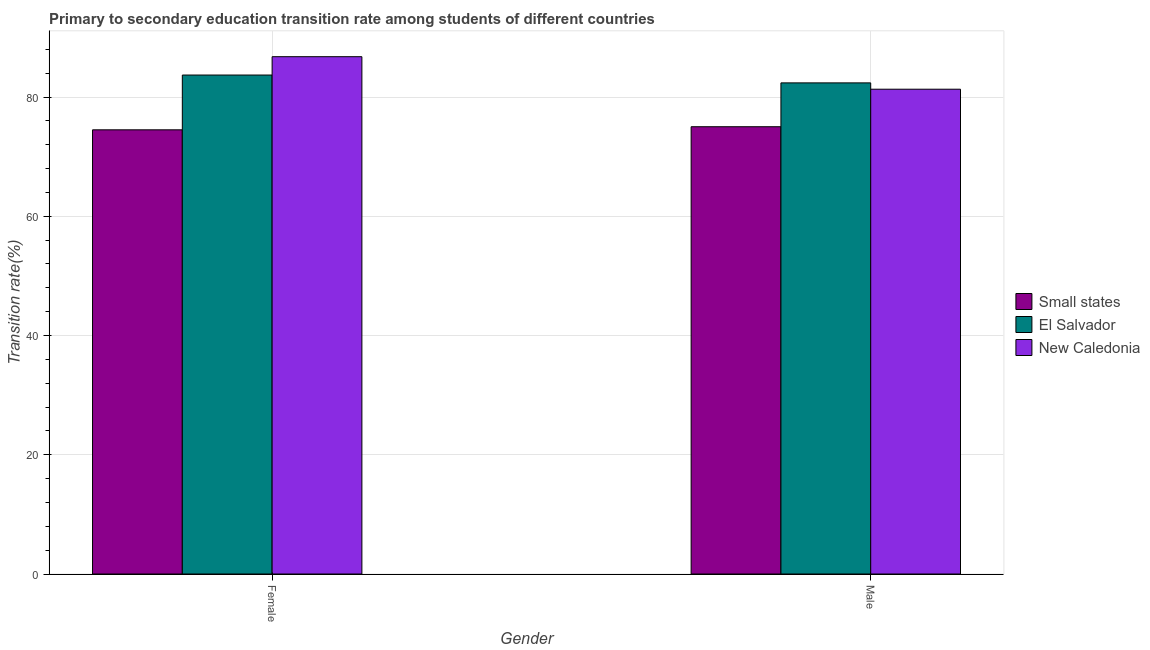How many different coloured bars are there?
Your response must be concise. 3. Are the number of bars per tick equal to the number of legend labels?
Keep it short and to the point. Yes. What is the label of the 1st group of bars from the left?
Provide a short and direct response. Female. What is the transition rate among male students in Small states?
Ensure brevity in your answer.  75.02. Across all countries, what is the maximum transition rate among male students?
Provide a short and direct response. 82.38. Across all countries, what is the minimum transition rate among male students?
Offer a very short reply. 75.02. In which country was the transition rate among female students maximum?
Offer a terse response. New Caledonia. In which country was the transition rate among male students minimum?
Offer a terse response. Small states. What is the total transition rate among male students in the graph?
Provide a succinct answer. 238.71. What is the difference between the transition rate among male students in El Salvador and that in Small states?
Give a very brief answer. 7.35. What is the difference between the transition rate among female students in El Salvador and the transition rate among male students in Small states?
Make the answer very short. 8.67. What is the average transition rate among female students per country?
Give a very brief answer. 81.65. What is the difference between the transition rate among male students and transition rate among female students in New Caledonia?
Provide a succinct answer. -5.45. What is the ratio of the transition rate among female students in Small states to that in New Caledonia?
Offer a terse response. 0.86. Is the transition rate among female students in El Salvador less than that in Small states?
Provide a succinct answer. No. In how many countries, is the transition rate among female students greater than the average transition rate among female students taken over all countries?
Ensure brevity in your answer.  2. What does the 3rd bar from the left in Female represents?
Your answer should be compact. New Caledonia. What does the 1st bar from the right in Male represents?
Your answer should be compact. New Caledonia. Are all the bars in the graph horizontal?
Your answer should be very brief. No. Does the graph contain any zero values?
Provide a short and direct response. No. How are the legend labels stacked?
Offer a very short reply. Vertical. What is the title of the graph?
Offer a terse response. Primary to secondary education transition rate among students of different countries. What is the label or title of the X-axis?
Ensure brevity in your answer.  Gender. What is the label or title of the Y-axis?
Provide a short and direct response. Transition rate(%). What is the Transition rate(%) in Small states in Female?
Offer a terse response. 74.5. What is the Transition rate(%) in El Salvador in Female?
Make the answer very short. 83.69. What is the Transition rate(%) of New Caledonia in Female?
Offer a very short reply. 86.77. What is the Transition rate(%) of Small states in Male?
Offer a very short reply. 75.02. What is the Transition rate(%) in El Salvador in Male?
Your answer should be compact. 82.38. What is the Transition rate(%) of New Caledonia in Male?
Offer a terse response. 81.31. Across all Gender, what is the maximum Transition rate(%) in Small states?
Your response must be concise. 75.02. Across all Gender, what is the maximum Transition rate(%) of El Salvador?
Provide a succinct answer. 83.69. Across all Gender, what is the maximum Transition rate(%) in New Caledonia?
Your answer should be very brief. 86.77. Across all Gender, what is the minimum Transition rate(%) of Small states?
Your response must be concise. 74.5. Across all Gender, what is the minimum Transition rate(%) of El Salvador?
Make the answer very short. 82.38. Across all Gender, what is the minimum Transition rate(%) in New Caledonia?
Keep it short and to the point. 81.31. What is the total Transition rate(%) in Small states in the graph?
Your response must be concise. 149.52. What is the total Transition rate(%) of El Salvador in the graph?
Ensure brevity in your answer.  166.07. What is the total Transition rate(%) of New Caledonia in the graph?
Keep it short and to the point. 168.08. What is the difference between the Transition rate(%) in Small states in Female and that in Male?
Ensure brevity in your answer.  -0.52. What is the difference between the Transition rate(%) in El Salvador in Female and that in Male?
Your answer should be compact. 1.32. What is the difference between the Transition rate(%) in New Caledonia in Female and that in Male?
Give a very brief answer. 5.45. What is the difference between the Transition rate(%) in Small states in Female and the Transition rate(%) in El Salvador in Male?
Make the answer very short. -7.87. What is the difference between the Transition rate(%) in Small states in Female and the Transition rate(%) in New Caledonia in Male?
Keep it short and to the point. -6.81. What is the difference between the Transition rate(%) of El Salvador in Female and the Transition rate(%) of New Caledonia in Male?
Your answer should be compact. 2.38. What is the average Transition rate(%) of Small states per Gender?
Your answer should be very brief. 74.76. What is the average Transition rate(%) of El Salvador per Gender?
Keep it short and to the point. 83.03. What is the average Transition rate(%) in New Caledonia per Gender?
Make the answer very short. 84.04. What is the difference between the Transition rate(%) of Small states and Transition rate(%) of El Salvador in Female?
Provide a succinct answer. -9.19. What is the difference between the Transition rate(%) of Small states and Transition rate(%) of New Caledonia in Female?
Make the answer very short. -12.27. What is the difference between the Transition rate(%) of El Salvador and Transition rate(%) of New Caledonia in Female?
Provide a succinct answer. -3.08. What is the difference between the Transition rate(%) in Small states and Transition rate(%) in El Salvador in Male?
Your answer should be compact. -7.36. What is the difference between the Transition rate(%) of Small states and Transition rate(%) of New Caledonia in Male?
Provide a succinct answer. -6.29. What is the difference between the Transition rate(%) in El Salvador and Transition rate(%) in New Caledonia in Male?
Ensure brevity in your answer.  1.06. What is the ratio of the Transition rate(%) in Small states in Female to that in Male?
Provide a short and direct response. 0.99. What is the ratio of the Transition rate(%) of El Salvador in Female to that in Male?
Provide a short and direct response. 1.02. What is the ratio of the Transition rate(%) of New Caledonia in Female to that in Male?
Offer a terse response. 1.07. What is the difference between the highest and the second highest Transition rate(%) in Small states?
Your answer should be compact. 0.52. What is the difference between the highest and the second highest Transition rate(%) in El Salvador?
Your answer should be very brief. 1.32. What is the difference between the highest and the second highest Transition rate(%) of New Caledonia?
Your answer should be very brief. 5.45. What is the difference between the highest and the lowest Transition rate(%) of Small states?
Your answer should be compact. 0.52. What is the difference between the highest and the lowest Transition rate(%) of El Salvador?
Ensure brevity in your answer.  1.32. What is the difference between the highest and the lowest Transition rate(%) in New Caledonia?
Your response must be concise. 5.45. 